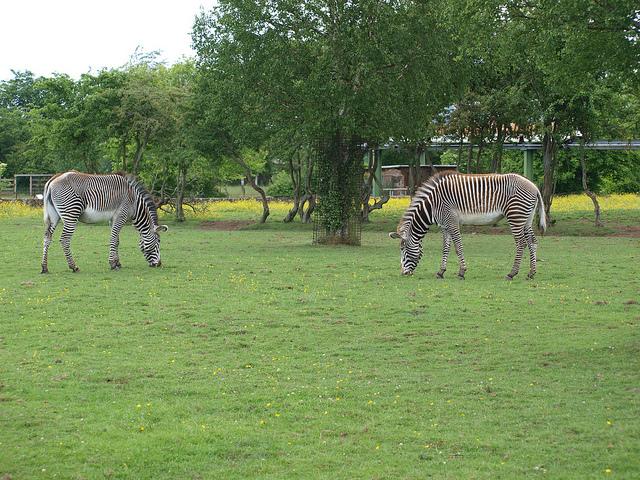What are the zebra doing?
Write a very short answer. Grazing. Was this pic taken are the zoo or in the wild?
Be succinct. Zoo. How many zebras are in this photo?
Concise answer only. 2. 